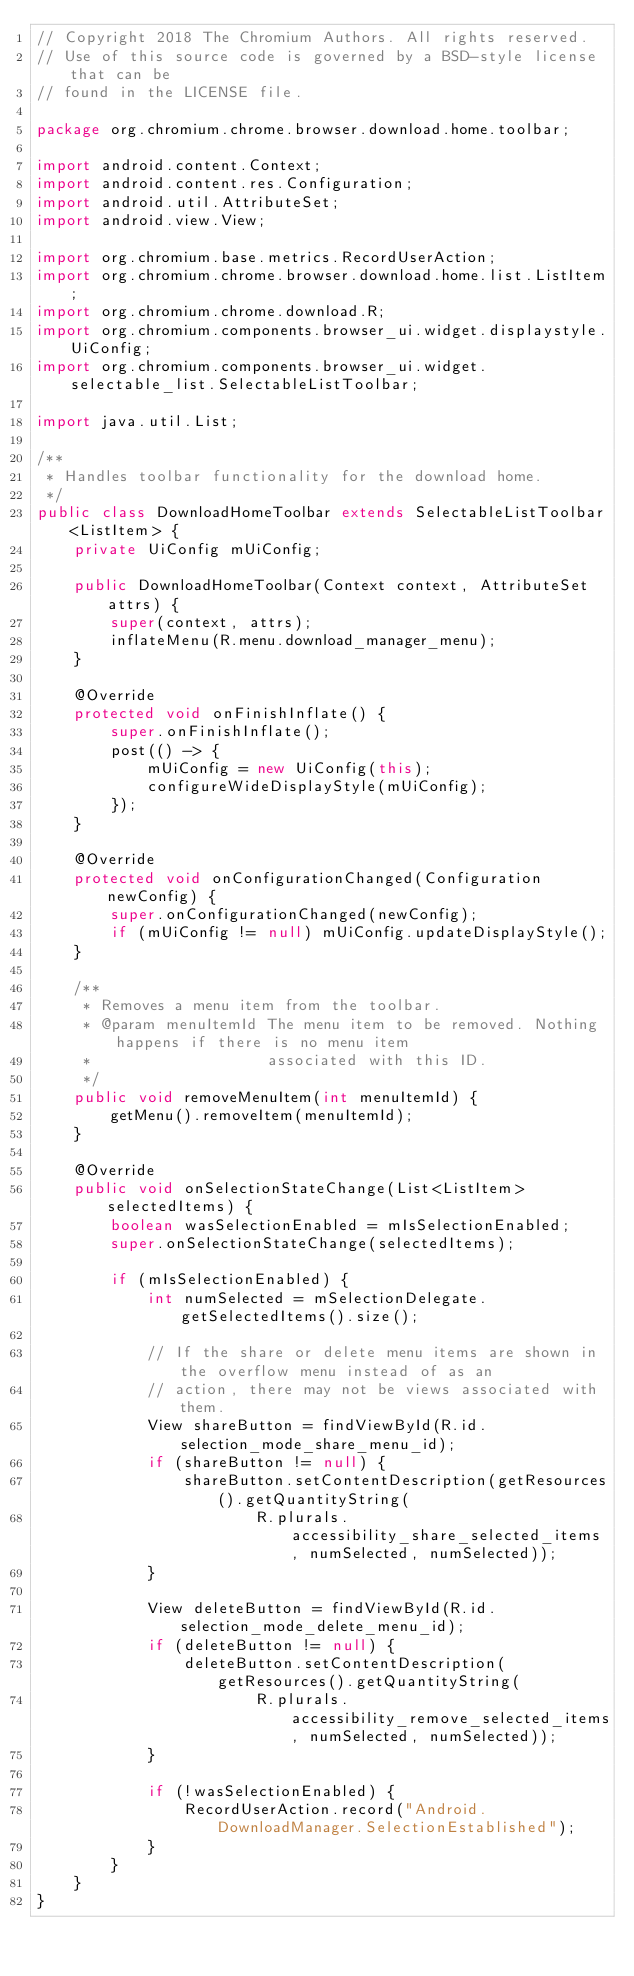<code> <loc_0><loc_0><loc_500><loc_500><_Java_>// Copyright 2018 The Chromium Authors. All rights reserved.
// Use of this source code is governed by a BSD-style license that can be
// found in the LICENSE file.

package org.chromium.chrome.browser.download.home.toolbar;

import android.content.Context;
import android.content.res.Configuration;
import android.util.AttributeSet;
import android.view.View;

import org.chromium.base.metrics.RecordUserAction;
import org.chromium.chrome.browser.download.home.list.ListItem;
import org.chromium.chrome.download.R;
import org.chromium.components.browser_ui.widget.displaystyle.UiConfig;
import org.chromium.components.browser_ui.widget.selectable_list.SelectableListToolbar;

import java.util.List;

/**
 * Handles toolbar functionality for the download home.
 */
public class DownloadHomeToolbar extends SelectableListToolbar<ListItem> {
    private UiConfig mUiConfig;

    public DownloadHomeToolbar(Context context, AttributeSet attrs) {
        super(context, attrs);
        inflateMenu(R.menu.download_manager_menu);
    }

    @Override
    protected void onFinishInflate() {
        super.onFinishInflate();
        post(() -> {
            mUiConfig = new UiConfig(this);
            configureWideDisplayStyle(mUiConfig);
        });
    }

    @Override
    protected void onConfigurationChanged(Configuration newConfig) {
        super.onConfigurationChanged(newConfig);
        if (mUiConfig != null) mUiConfig.updateDisplayStyle();
    }

    /**
     * Removes a menu item from the toolbar.
     * @param menuItemId The menu item to be removed. Nothing happens if there is no menu item
     *                   associated with this ID.
     */
    public void removeMenuItem(int menuItemId) {
        getMenu().removeItem(menuItemId);
    }

    @Override
    public void onSelectionStateChange(List<ListItem> selectedItems) {
        boolean wasSelectionEnabled = mIsSelectionEnabled;
        super.onSelectionStateChange(selectedItems);

        if (mIsSelectionEnabled) {
            int numSelected = mSelectionDelegate.getSelectedItems().size();

            // If the share or delete menu items are shown in the overflow menu instead of as an
            // action, there may not be views associated with them.
            View shareButton = findViewById(R.id.selection_mode_share_menu_id);
            if (shareButton != null) {
                shareButton.setContentDescription(getResources().getQuantityString(
                        R.plurals.accessibility_share_selected_items, numSelected, numSelected));
            }

            View deleteButton = findViewById(R.id.selection_mode_delete_menu_id);
            if (deleteButton != null) {
                deleteButton.setContentDescription(getResources().getQuantityString(
                        R.plurals.accessibility_remove_selected_items, numSelected, numSelected));
            }

            if (!wasSelectionEnabled) {
                RecordUserAction.record("Android.DownloadManager.SelectionEstablished");
            }
        }
    }
}
</code> 